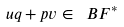Convert formula to latex. <formula><loc_0><loc_0><loc_500><loc_500>u q + p v \in \ B F ^ { * }</formula> 